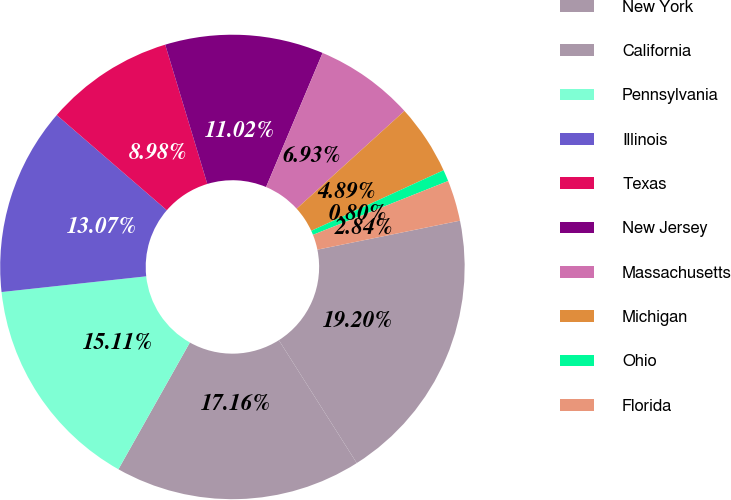<chart> <loc_0><loc_0><loc_500><loc_500><pie_chart><fcel>New York<fcel>California<fcel>Pennsylvania<fcel>Illinois<fcel>Texas<fcel>New Jersey<fcel>Massachusetts<fcel>Michigan<fcel>Ohio<fcel>Florida<nl><fcel>19.2%<fcel>17.16%<fcel>15.11%<fcel>13.07%<fcel>8.98%<fcel>11.02%<fcel>6.93%<fcel>4.89%<fcel>0.8%<fcel>2.84%<nl></chart> 